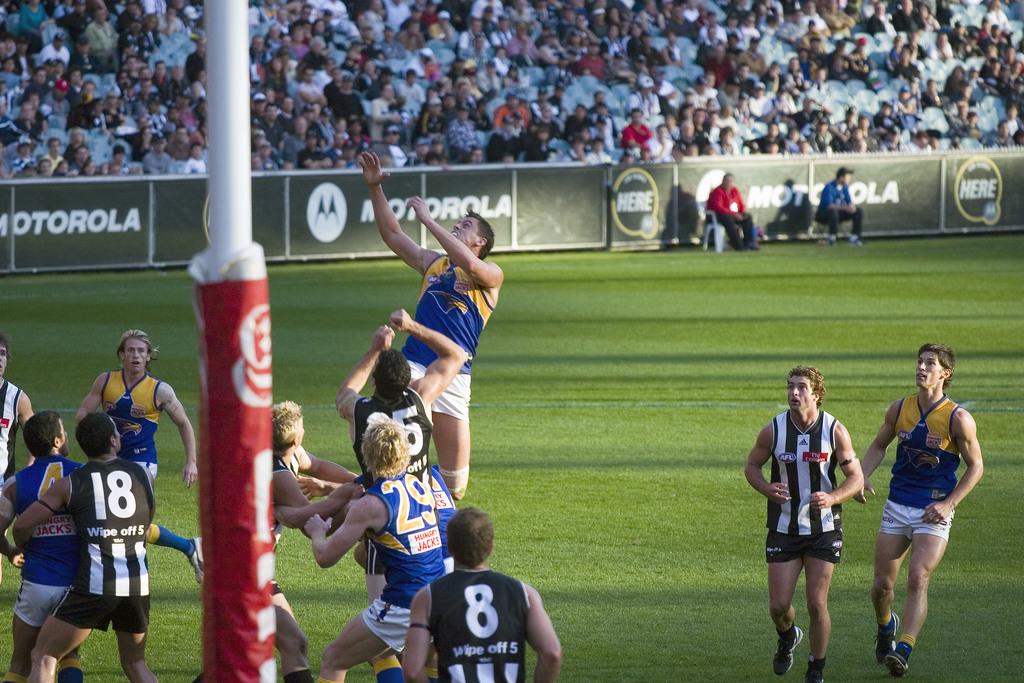Who sponsors this field?
Offer a terse response. Motorola. 